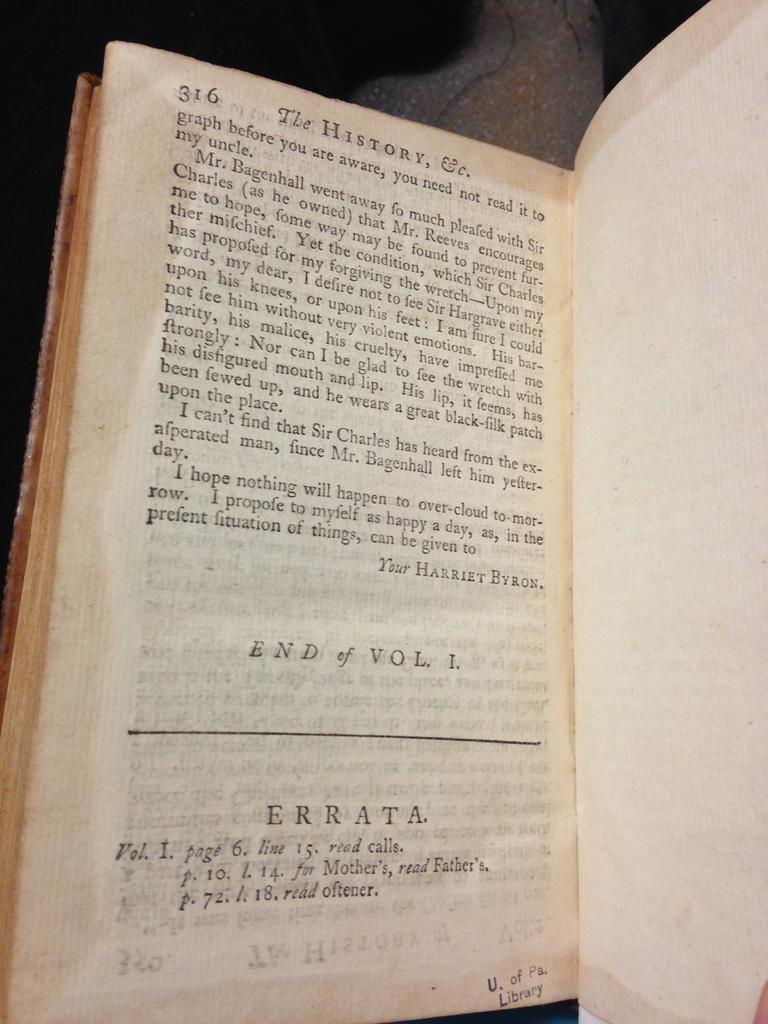<image>
Provide a brief description of the given image. The final page of the book The history Ec.volume one. 